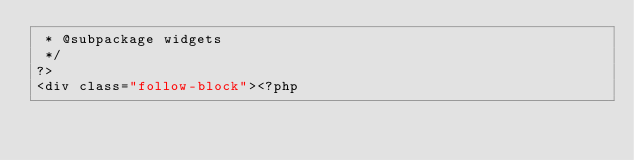<code> <loc_0><loc_0><loc_500><loc_500><_PHP_> * @subpackage widgets
 */
?>
<div class="follow-block"><?php
</code> 